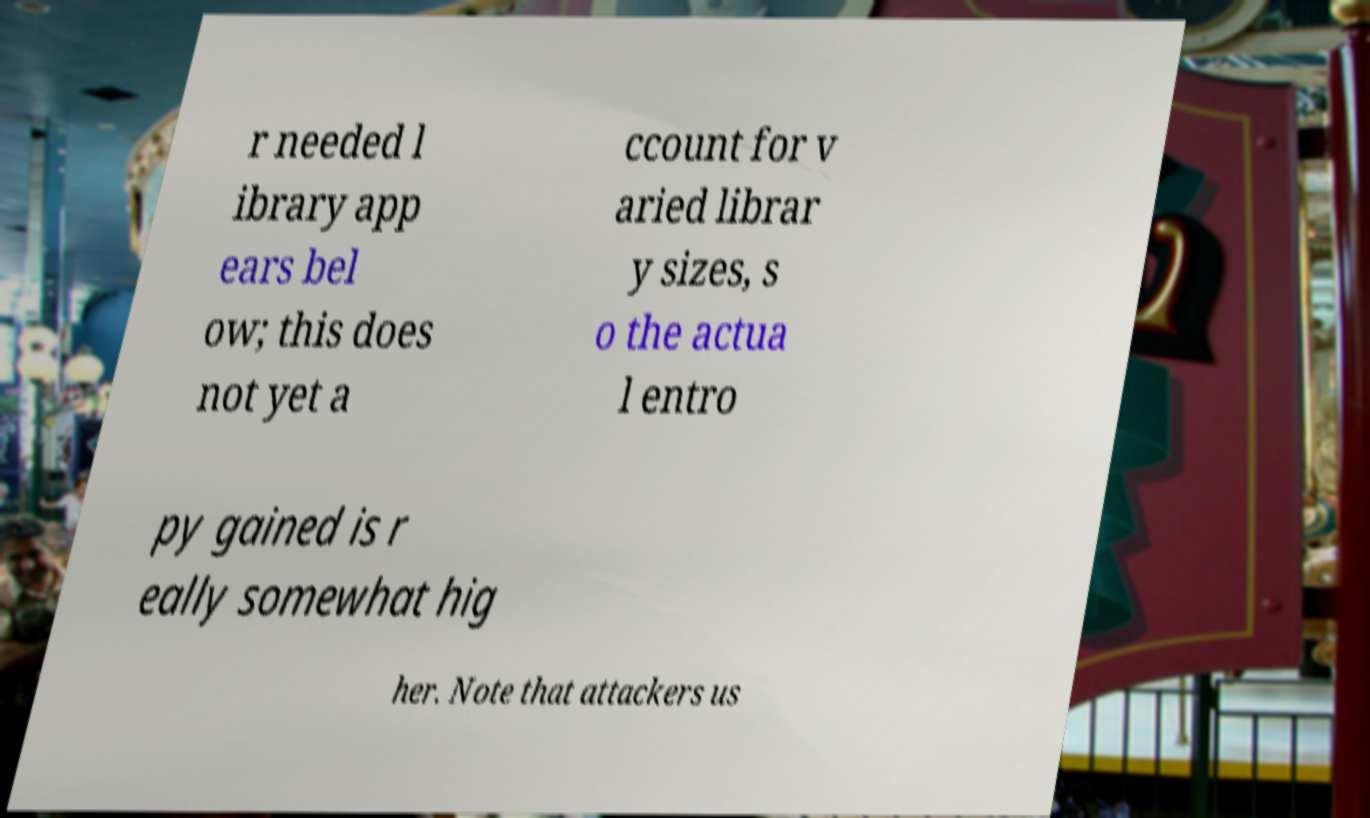Could you assist in decoding the text presented in this image and type it out clearly? r needed l ibrary app ears bel ow; this does not yet a ccount for v aried librar y sizes, s o the actua l entro py gained is r eally somewhat hig her. Note that attackers us 